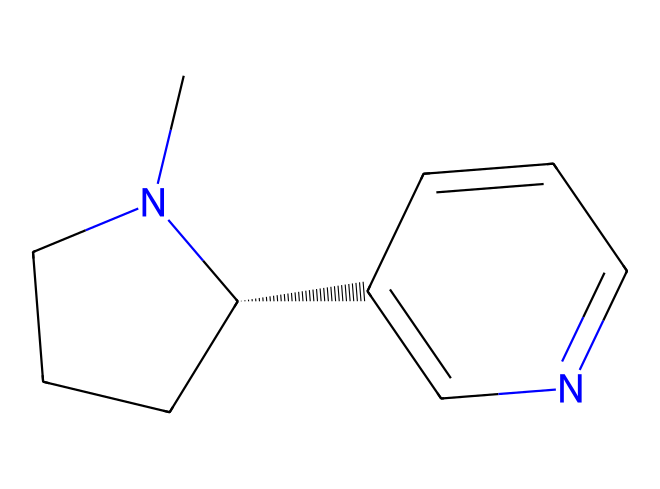What is the molecular formula of this compound? To determine the molecular formula from the SMILES notation, we identify the atoms present. The SMILES shows carbon (C), nitrogen (N), and hydrogen (H) atoms. By counting the atoms: 10 carbon atoms, 12 hydrogen atoms, and 2 nitrogen atoms, we arrive at C10H12N2 as the molecular formula.
Answer: C10H12N2 How many rings are present in this structure? The structure contains two rings, which can be identified by looking for cyclic structures in the SMILES notation. The ‘C1CCC’ indicates the start of one ring, while ‘C2=CN’ indicates another ring. Together, they confirm the presence of two cycles.
Answer: 2 What type of organic compound is nicotine classified as? Nicotine contains nitrogen and has alkaloid characteristics; this means it fits into the category of alkaloids, which are nitrogen-containing compounds derived from plants, particularly notable for their biological effects. The presence of nitrogen confirms its classification as an alkaloid.
Answer: alkaloid What is the total number of nitrogen atoms in this compound? From the SMILES notation, we can see the presence of ‘N’ twice, indicating there are two nitrogen atoms within the chemical structure. By counting each occurrence of the nitrogen symbol, the total comes out to two.
Answer: 2 Is this compound aromatic? To determine if the compound is aromatic, we examine the presence of cyclic structures with alternating double bonds and the level of delocalization of electrons. This compound has a ring structure with double bonds, specifically the pyridine-like context, indicating it has aromatic character.
Answer: yes What functional groups are present in nicotine? By analyzing the SMILES structure, we note the occurrence of a nitrogen atom and multiple carbon-hydrogen frameworks that form part of an amine group. The presence of nitrogen, particularly within aromatic systems, suggests the presence of an amine functional group. Therefore, the key functional group identified here is the amine.
Answer: amine 